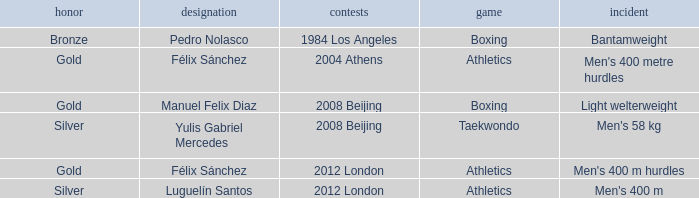What Medal had a Name of manuel felix diaz? Gold. 